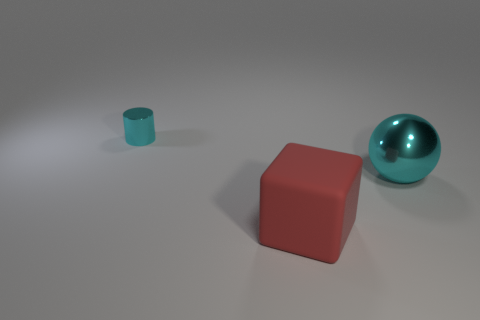What number of tiny cyan metallic cylinders are in front of the matte thing that is on the right side of the cyan shiny object to the left of the red thing?
Provide a succinct answer. 0. How many big red matte things are there?
Give a very brief answer. 1. Are there fewer red things that are on the right side of the big cube than large cyan balls that are left of the big cyan shiny ball?
Offer a terse response. No. Is the number of cyan balls that are behind the cyan ball less than the number of big green matte objects?
Provide a short and direct response. No. What is the material of the big red cube left of the cyan metallic thing that is in front of the metal object behind the cyan sphere?
Offer a very short reply. Rubber. What number of things are either metal objects that are on the right side of the matte object or shiny things that are on the left side of the red matte object?
Your answer should be compact. 2. Are there an equal number of small cyan things and big green matte cylinders?
Make the answer very short. No. How many rubber things are either red cylinders or tiny things?
Make the answer very short. 0. There is a large cyan thing that is made of the same material as the cylinder; what shape is it?
Give a very brief answer. Sphere. How many cyan things have the same shape as the red object?
Offer a very short reply. 0. 